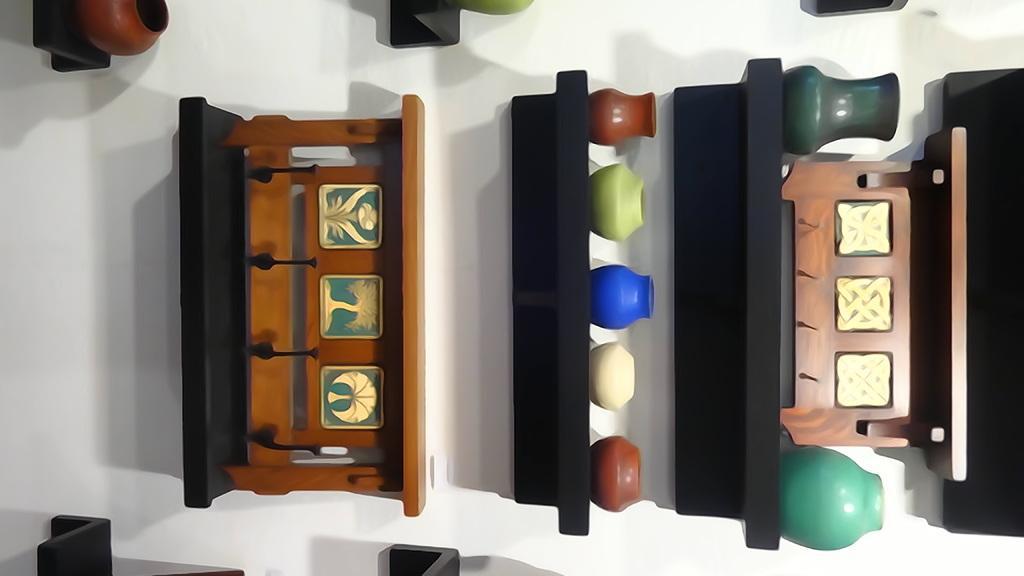Could you give a brief overview of what you see in this image? In this image there are few shelves having few crockery items on it. Shelves are attached to the wall. 